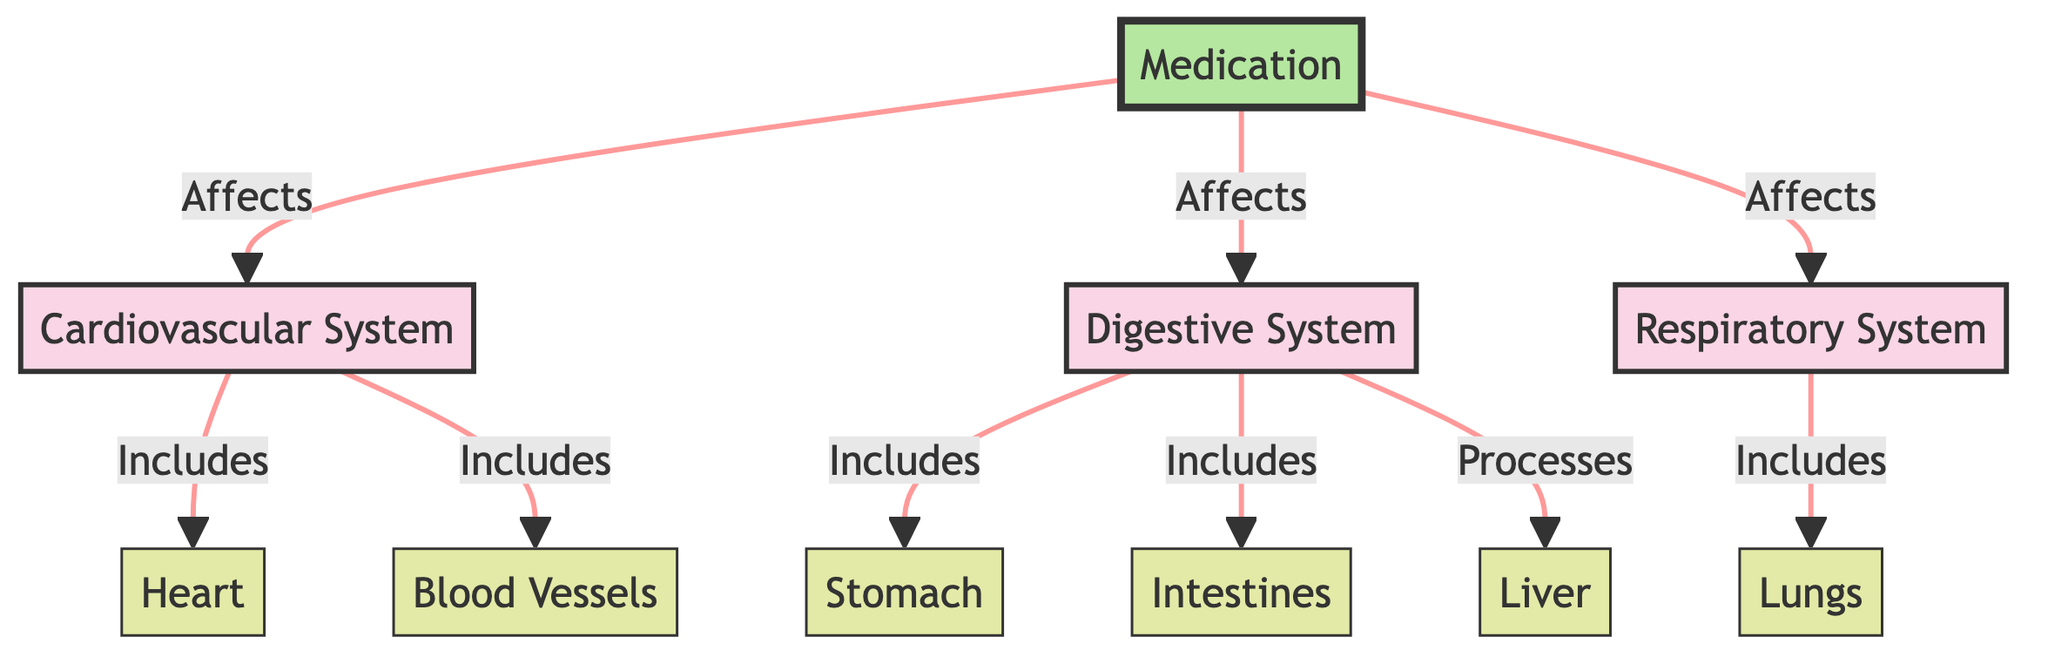What systems are affected by medication? The flow diagram shows that medication affects the cardiovascular, digestive, and respiratory systems. Each system is directly linked to the medication node, indicating their interaction.
Answer: cardiovascular, digestive, respiratory How many organs are included in the cardiovascular system? The diagram specifies that the cardiovascular system includes two organs: the heart and blood vessels. By counting the instances directly associated with this system, the answer is determined.
Answer: 2 What organ processes medications in the digestive system? The diagram indicates that the liver is responsible for processing medications. It directly states "Processes" in relation to the liver under the digestive system.
Answer: liver Which organ is part of the respiratory system? The diagram shows that the lungs are included in the respiratory system. This information is clearly represented in the flowchart as a part of that system.
Answer: lungs How many major body systems are depicted in the diagram? The diagram illustrates three major body systems: the cardiovascular, digestive, and respiratory systems. This can be counted by identifying distinct systems indicated in the flowchart.
Answer: 3 What is the connection between medication and the digestive system? The diagram indicates that medication affects the digestive system, as shown by the arrow connecting the medication node to the digestive system. This direct relationship illustrates their interaction.
Answer: Affects Which organ is not part of the cardiovascular system? The diagram includes organs from the cardiovascular, digestive, and respiratory systems. By identifying the organs specific to cardiovascular (heart, blood vessels), it's clear that organs like the stomach or intestines do not belong to this system.
Answer: stomach What does the arrow between medication and cardiovascular system represent? The arrow signifies that medication has an effect on the cardiovascular system, explicitly described in the flowchart as an impact of medication on that system.
Answer: Affects 